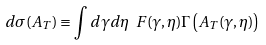<formula> <loc_0><loc_0><loc_500><loc_500>d \sigma ( A _ { T } ) \equiv \int d \gamma d \eta \ F ( \gamma , \eta ) \Gamma \left ( A _ { T } ( \gamma , \eta ) \right )</formula> 